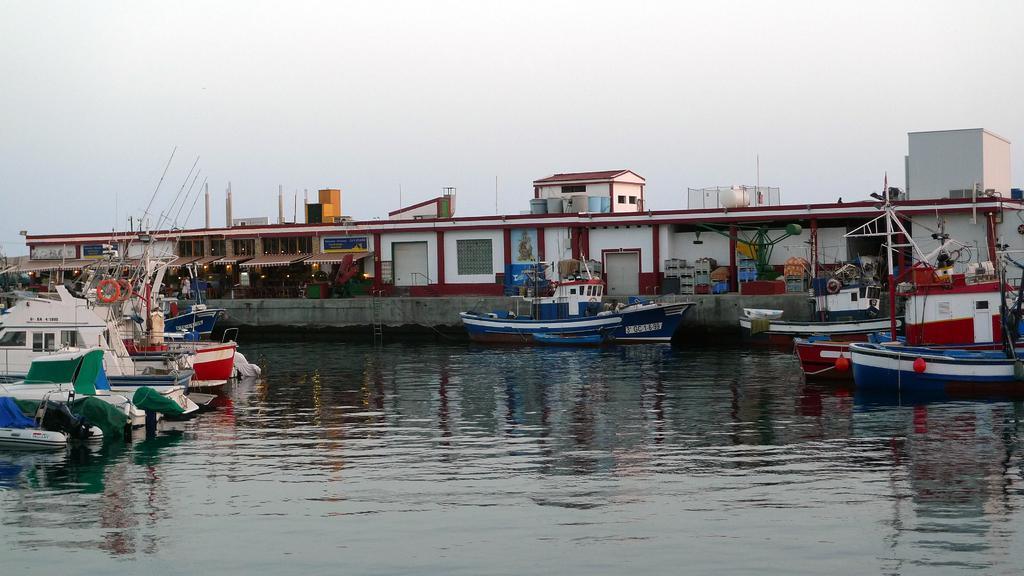How would you summarize this image in a sentence or two? In this picture we can see a few boats on the water. There are poles and orange objects in these boats. We can see a few houses and lights in these houses. 